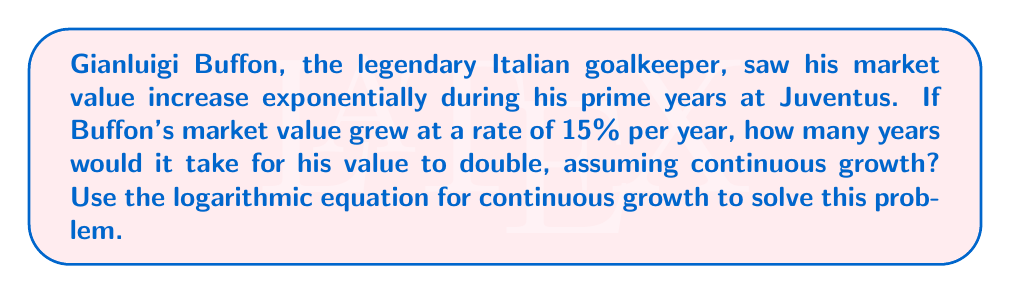What is the answer to this math problem? Let's approach this step-by-step using the continuous growth formula:

1) The continuous growth formula is:
   $$A = P \cdot e^{rt}$$
   Where:
   $A$ = final amount
   $P$ = initial amount
   $r$ = growth rate (as a decimal)
   $t$ = time
   $e$ = Euler's number (approximately 2.71828)

2) We want to find when the value doubles, so:
   $$2P = P \cdot e^{rt}$$

3) Divide both sides by $P$:
   $$2 = e^{rt}$$

4) Take the natural log of both sides:
   $$\ln(2) = \ln(e^{rt})$$

5) Simplify the right side using the properties of logarithms:
   $$\ln(2) = rt$$

6) Solve for $t$:
   $$t = \frac{\ln(2)}{r}$$

7) We know $r = 0.15$ (15% expressed as a decimal), so:
   $$t = \frac{\ln(2)}{0.15}$$

8) Calculate:
   $$t \approx 4.62 \text{ years}$$

Thus, it would take approximately 4.62 years for Buffon's market value to double at a continuous growth rate of 15% per year.
Answer: 4.62 years 